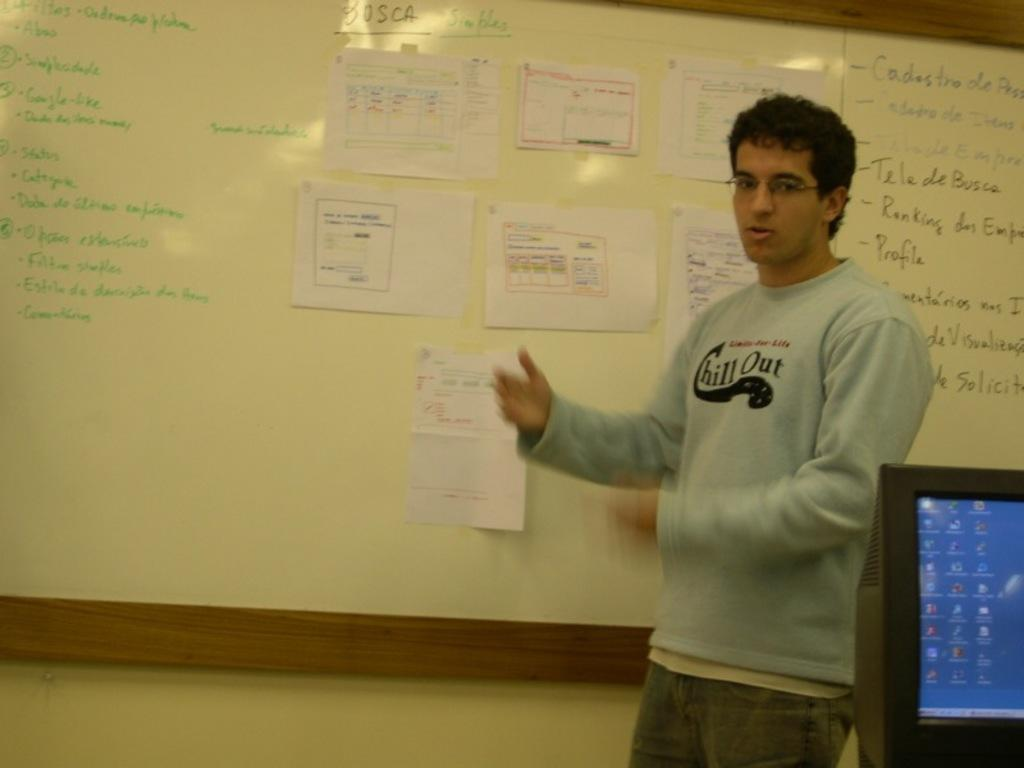<image>
Render a clear and concise summary of the photo. a shirt with the words chill out on it 